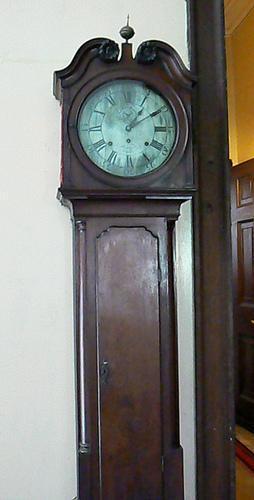How many clocks are there?
Give a very brief answer. 1. 